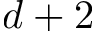Convert formula to latex. <formula><loc_0><loc_0><loc_500><loc_500>d + 2</formula> 